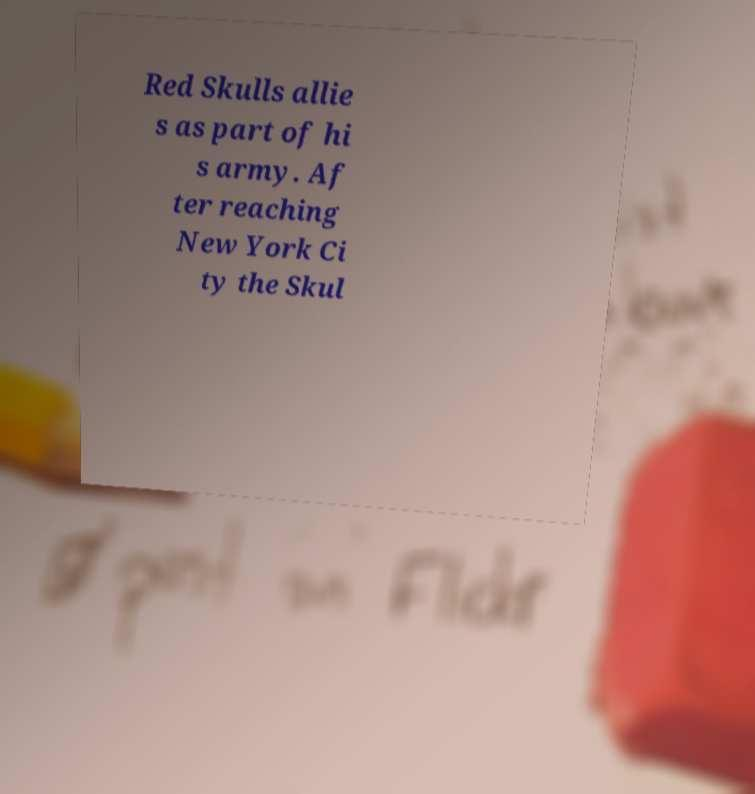Can you accurately transcribe the text from the provided image for me? Red Skulls allie s as part of hi s army. Af ter reaching New York Ci ty the Skul 